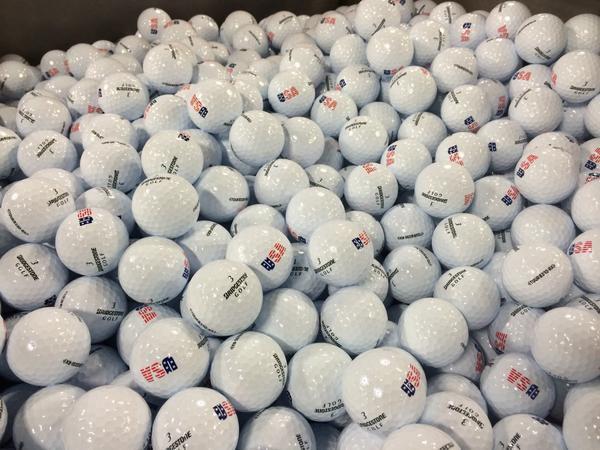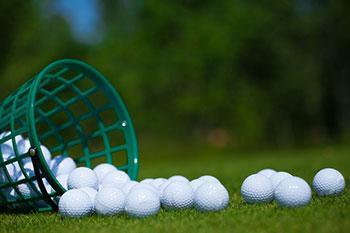The first image is the image on the left, the second image is the image on the right. Given the left and right images, does the statement "Balls are pouring out of a mesh green basket." hold true? Answer yes or no. Yes. The first image is the image on the left, the second image is the image on the right. Examine the images to the left and right. Is the description "An image features a tipped-over mesh-type bucket spilling golf balls." accurate? Answer yes or no. Yes. 